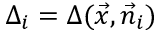<formula> <loc_0><loc_0><loc_500><loc_500>\Delta _ { i } = \Delta ( \vec { x } , \vec { n } _ { i } )</formula> 